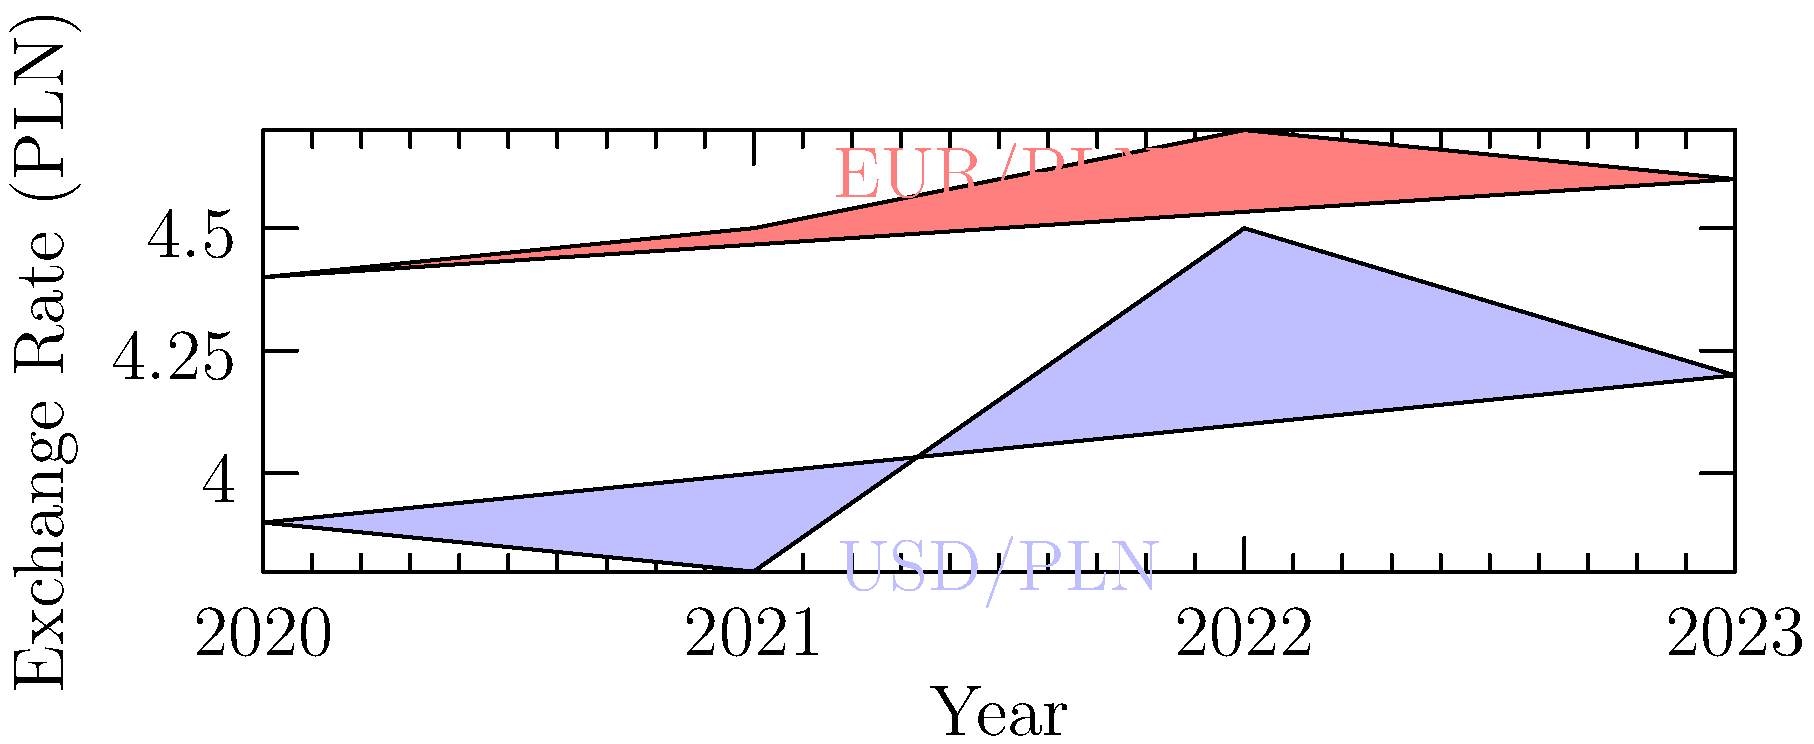Based on the area chart showing exchange rates for USD/PLN and EUR/PLN from 2020 to 2023, which currency pair exhibited greater volatility, and what potential investment strategy could be derived from this information? To answer this question, we need to analyze the exchange rate movements for both currency pairs:

1. USD/PLN (represented by the blue area):
   - 2020: 3.9
   - 2021: 3.8 (slight decrease)
   - 2022: 4.5 (significant increase)
   - 2023: 4.2 (moderate decrease)

2. EUR/PLN (represented by the red area):
   - 2020: 4.4
   - 2021: 4.5 (slight increase)
   - 2022: 4.7 (moderate increase)
   - 2023: 4.6 (slight decrease)

3. Comparing volatility:
   - USD/PLN shows larger fluctuations, especially the sharp increase from 2021 to 2022.
   - EUR/PLN demonstrates more stable movement with smaller changes year-over-year.

4. Volatility calculation:
   - USD/PLN range: 4.5 - 3.8 = 0.7 PLN
   - EUR/PLN range: 4.7 - 4.4 = 0.3 PLN

5. Investment strategy:
   - Higher volatility in USD/PLN suggests more opportunities for profit (and risk) in short-term trading.
   - More stable EUR/PLN might be preferred for long-term, lower-risk investments.

Given the persona of a Polish businesswoman looking for lucrative investment opportunities, a strategy could involve:
- Capitalizing on USD/PLN volatility for short-term gains through forex trading or currency futures.
- Using EUR/PLN stability for hedging against currency risk in international business transactions.
Answer: USD/PLN showed greater volatility; short-term trading USD/PLN for potential gains, while using EUR/PLN for stable long-term investments and hedging. 